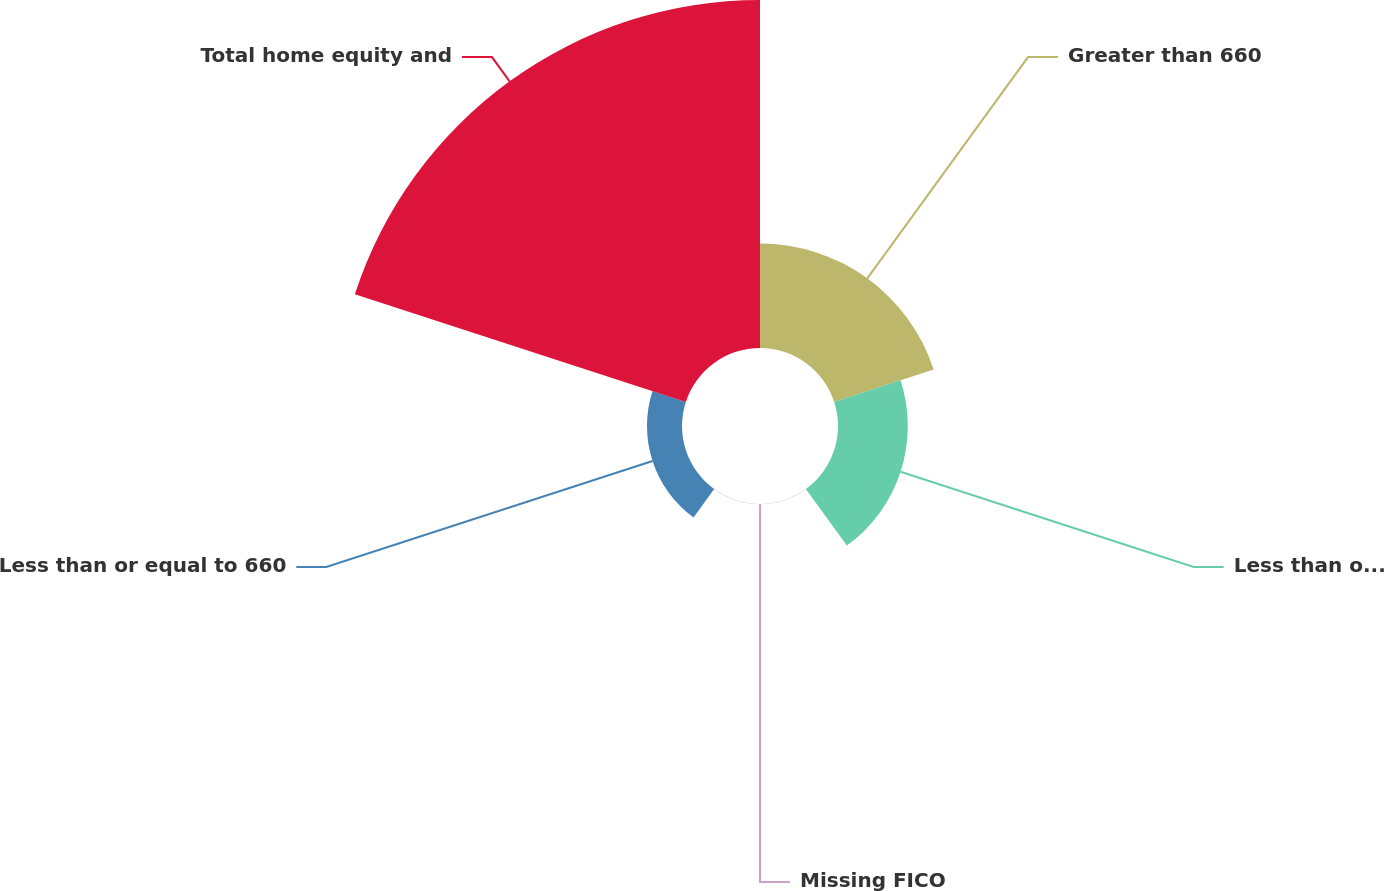Convert chart. <chart><loc_0><loc_0><loc_500><loc_500><pie_chart><fcel>Greater than 660<fcel>Less than or equal to 660 (d)<fcel>Missing FICO<fcel>Less than or equal to 660<fcel>Total home equity and<nl><fcel>18.75%<fcel>12.52%<fcel>0.04%<fcel>6.28%<fcel>62.41%<nl></chart> 